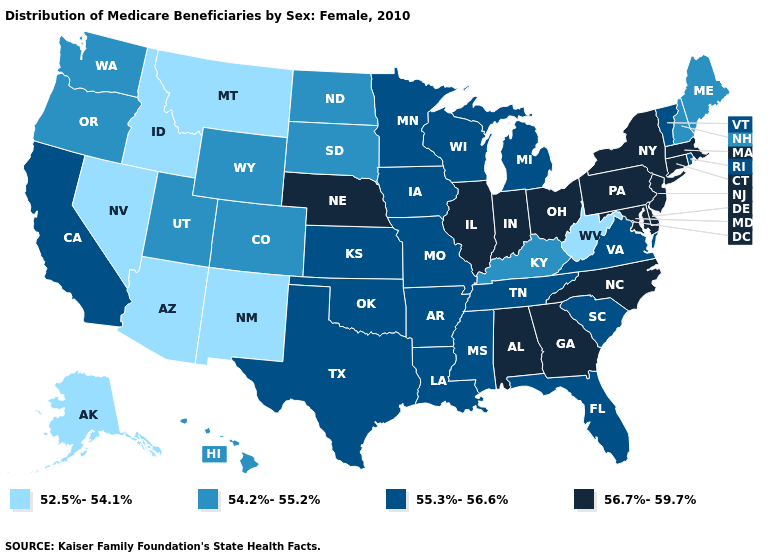How many symbols are there in the legend?
Concise answer only. 4. What is the highest value in states that border New York?
Answer briefly. 56.7%-59.7%. What is the highest value in the Northeast ?
Write a very short answer. 56.7%-59.7%. What is the value of Nebraska?
Give a very brief answer. 56.7%-59.7%. What is the lowest value in the Northeast?
Keep it brief. 54.2%-55.2%. Among the states that border North Carolina , which have the lowest value?
Write a very short answer. South Carolina, Tennessee, Virginia. Which states have the lowest value in the Northeast?
Answer briefly. Maine, New Hampshire. Is the legend a continuous bar?
Give a very brief answer. No. Name the states that have a value in the range 52.5%-54.1%?
Keep it brief. Alaska, Arizona, Idaho, Montana, Nevada, New Mexico, West Virginia. Does Michigan have the lowest value in the MidWest?
Be succinct. No. What is the highest value in the MidWest ?
Quick response, please. 56.7%-59.7%. Among the states that border Texas , which have the lowest value?
Quick response, please. New Mexico. Does Louisiana have a lower value than Georgia?
Keep it brief. Yes. Name the states that have a value in the range 54.2%-55.2%?
Keep it brief. Colorado, Hawaii, Kentucky, Maine, New Hampshire, North Dakota, Oregon, South Dakota, Utah, Washington, Wyoming. Among the states that border Arkansas , which have the lowest value?
Give a very brief answer. Louisiana, Mississippi, Missouri, Oklahoma, Tennessee, Texas. 